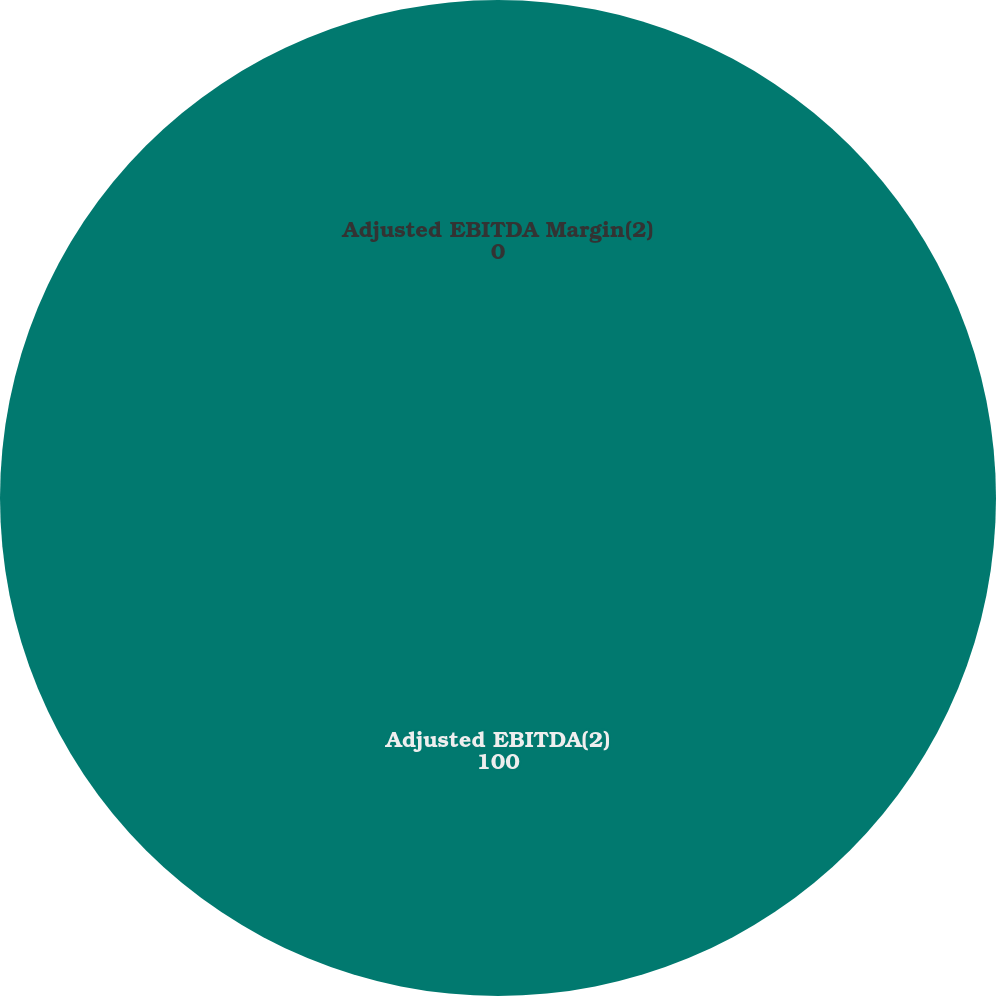Convert chart to OTSL. <chart><loc_0><loc_0><loc_500><loc_500><pie_chart><fcel>Adjusted EBITDA(2)<fcel>Adjusted EBITDA Margin(2)<nl><fcel>100.0%<fcel>0.0%<nl></chart> 